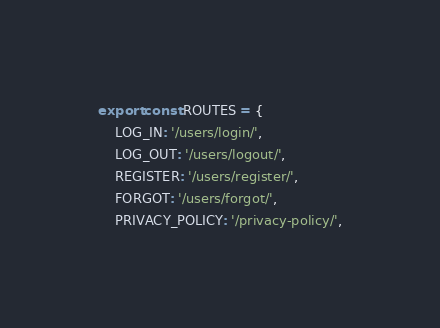<code> <loc_0><loc_0><loc_500><loc_500><_TypeScript_>export const ROUTES = {
    LOG_IN: '/users/login/',
    LOG_OUT: '/users/logout/',
    REGISTER: '/users/register/',
    FORGOT: '/users/forgot/',
    PRIVACY_POLICY: '/privacy-policy/',</code> 